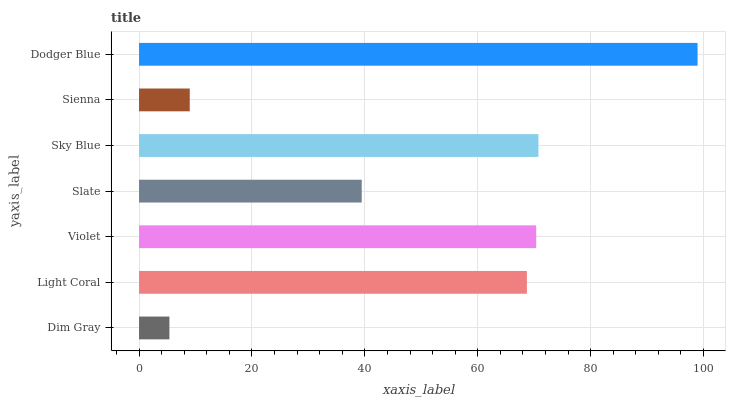Is Dim Gray the minimum?
Answer yes or no. Yes. Is Dodger Blue the maximum?
Answer yes or no. Yes. Is Light Coral the minimum?
Answer yes or no. No. Is Light Coral the maximum?
Answer yes or no. No. Is Light Coral greater than Dim Gray?
Answer yes or no. Yes. Is Dim Gray less than Light Coral?
Answer yes or no. Yes. Is Dim Gray greater than Light Coral?
Answer yes or no. No. Is Light Coral less than Dim Gray?
Answer yes or no. No. Is Light Coral the high median?
Answer yes or no. Yes. Is Light Coral the low median?
Answer yes or no. Yes. Is Sienna the high median?
Answer yes or no. No. Is Violet the low median?
Answer yes or no. No. 